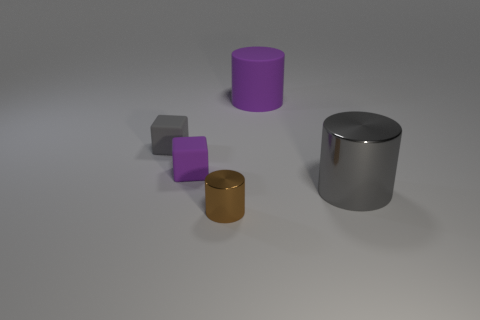There is a metallic cylinder that is to the left of the metallic cylinder that is right of the large cylinder behind the tiny purple matte block; what color is it?
Your answer should be compact. Brown. How many cyan things are either cylinders or small rubber objects?
Provide a short and direct response. 0. What number of other objects are the same size as the gray matte thing?
Provide a succinct answer. 2. How many big purple matte cylinders are there?
Keep it short and to the point. 1. Is there any other thing that has the same shape as the large purple thing?
Offer a terse response. Yes. Does the purple object right of the brown cylinder have the same material as the large object that is in front of the purple cylinder?
Your answer should be compact. No. What material is the brown cylinder?
Your answer should be compact. Metal. How many large objects have the same material as the gray cylinder?
Offer a very short reply. 0. What number of rubber things are big gray things or red cylinders?
Your answer should be very brief. 0. There is a tiny brown metal thing to the right of the tiny purple thing; is it the same shape as the gray thing on the left side of the big gray object?
Provide a short and direct response. No. 